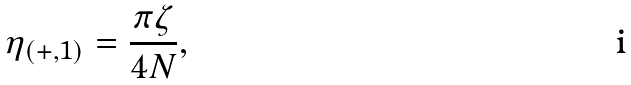Convert formula to latex. <formula><loc_0><loc_0><loc_500><loc_500>\eta _ { ( + , 1 ) } = \frac { \pi \zeta } { 4 N } ,</formula> 